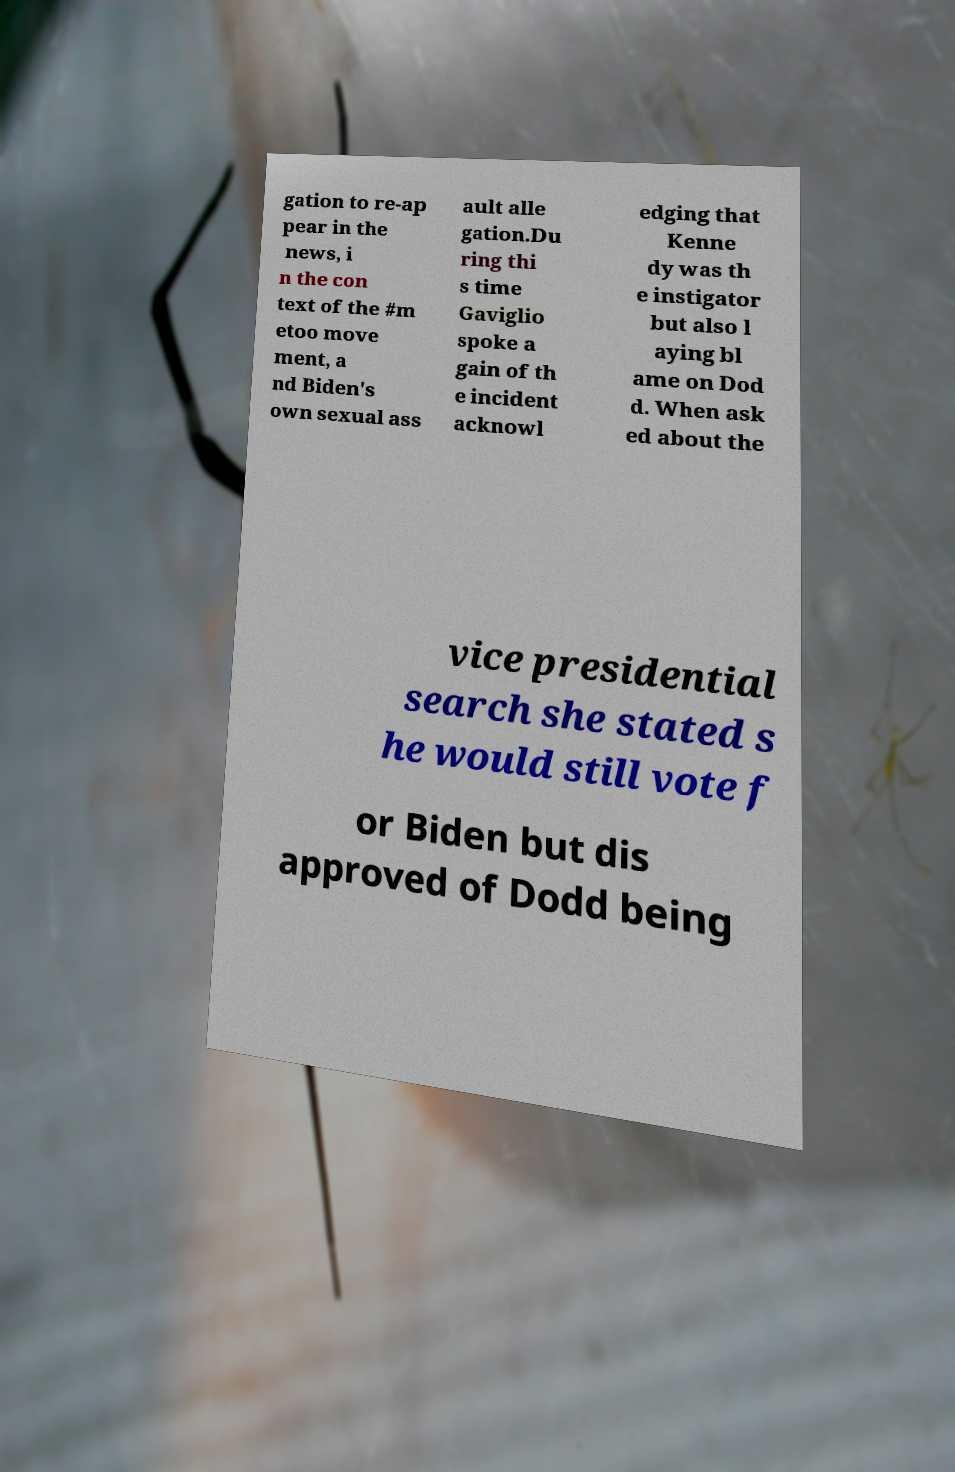Could you assist in decoding the text presented in this image and type it out clearly? gation to re-ap pear in the news, i n the con text of the #m etoo move ment, a nd Biden's own sexual ass ault alle gation.Du ring thi s time Gaviglio spoke a gain of th e incident acknowl edging that Kenne dy was th e instigator but also l aying bl ame on Dod d. When ask ed about the vice presidential search she stated s he would still vote f or Biden but dis approved of Dodd being 